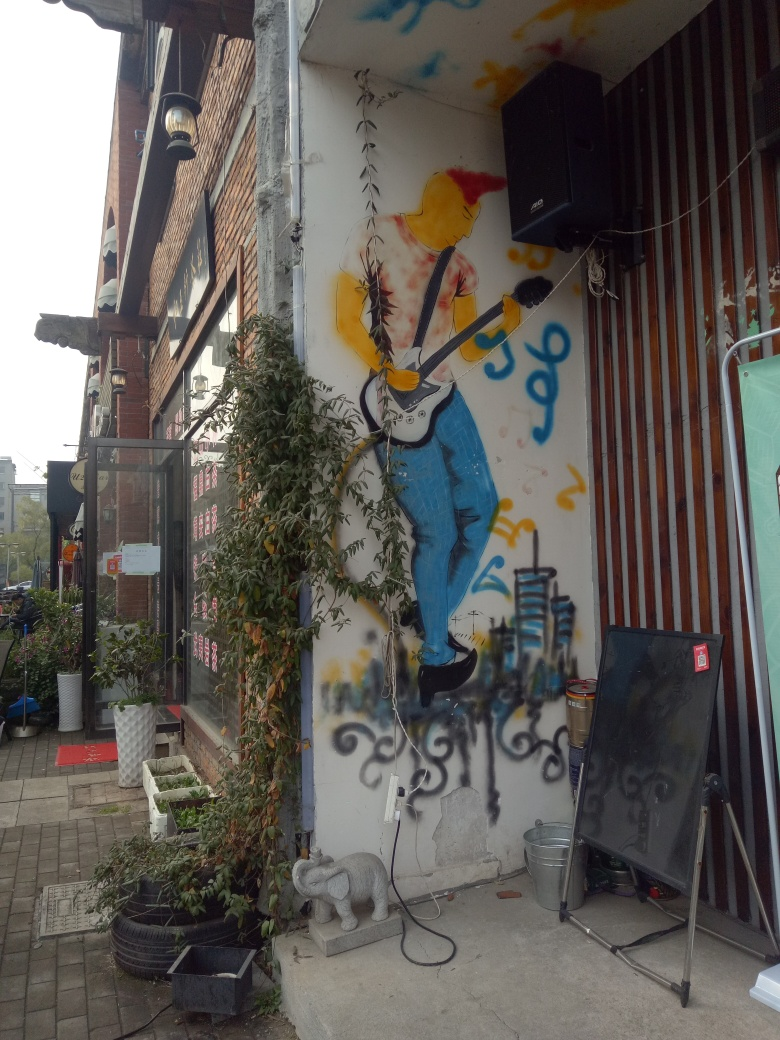Can you comment on the use of space and environment for this mural? Certainly, the placement of this mural on an urban building side adds an element of surprise and culture to an otherwise mundane setting. The artist has cleverly used the space, incorporating real-world objects, like the speaker and plants, into the scene, which adds a three-dimensional effect and ties the work to its environment. How does the mural interact with everyday objects around it like the speaker and the plants? The mural is in harmony with the speaker and plants, almost as if the figure is performing live at this spot. The speaker can be imagined as amplifying the music from the guitar, while the plants at the mural's edges seem to grow into the scene, further blurring the lines between art and reality, creating an immersive experience. 